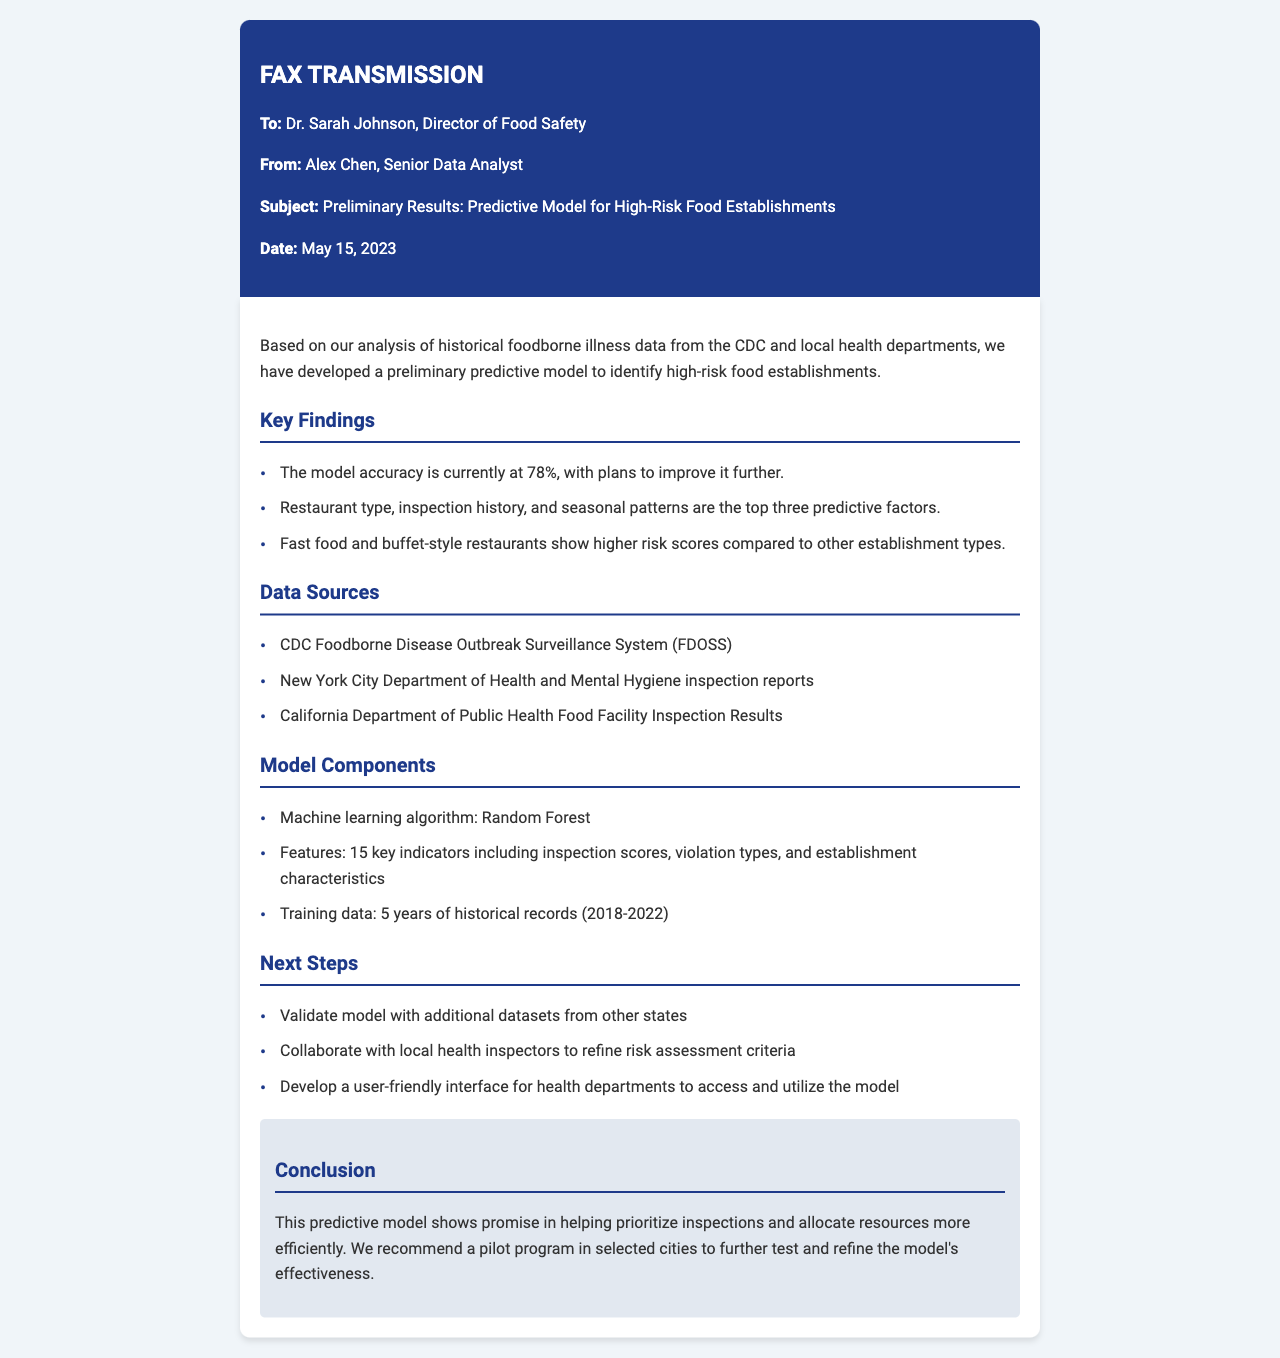what is the model accuracy? The document states that the model accuracy is currently at 78%.
Answer: 78% who is the recipient of the fax? The fax is addressed to Dr. Sarah Johnson, Director of Food Safety.
Answer: Dr. Sarah Johnson which machine learning algorithm is used in the model? The model utilizes the Random Forest algorithm as mentioned in the document.
Answer: Random Forest how many years of historical records were used for training data? The training data consists of 5 years of historical records from 2018 to 2022.
Answer: 5 years what are the top three predictive factors? The document lists restaurant type, inspection history, and seasonal patterns as the top three predictive factors.
Answer: Restaurant type, inspection history, seasonal patterns what is the next step mentioned for the model? One of the next steps is to validate the model with additional datasets from other states.
Answer: Validate model with additional datasets which establishment types have higher risk scores? Fast food and buffet-style restaurants show higher risk scores compared to other establishment types.
Answer: Fast food and buffet-style restaurants what kind of program is recommended to test the model? A pilot program in selected cities is recommended to further test and refine the model's effectiveness.
Answer: Pilot program 